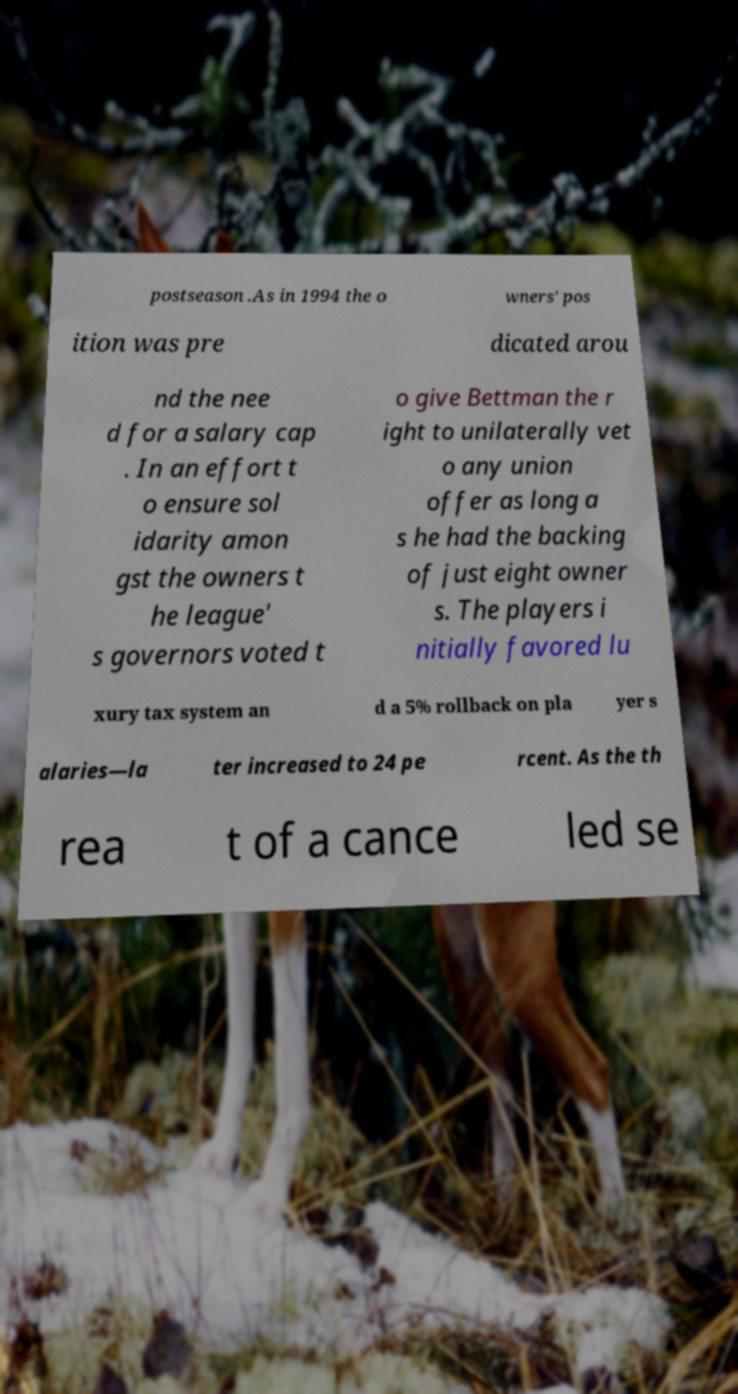I need the written content from this picture converted into text. Can you do that? postseason .As in 1994 the o wners' pos ition was pre dicated arou nd the nee d for a salary cap . In an effort t o ensure sol idarity amon gst the owners t he league' s governors voted t o give Bettman the r ight to unilaterally vet o any union offer as long a s he had the backing of just eight owner s. The players i nitially favored lu xury tax system an d a 5% rollback on pla yer s alaries—la ter increased to 24 pe rcent. As the th rea t of a cance led se 